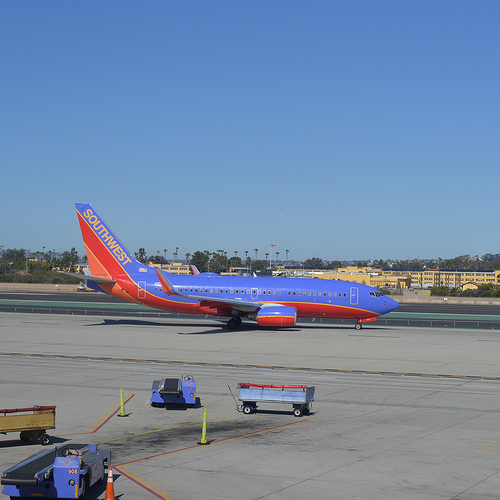<image>
Is the airplane above the runway? No. The airplane is not positioned above the runway. The vertical arrangement shows a different relationship. 